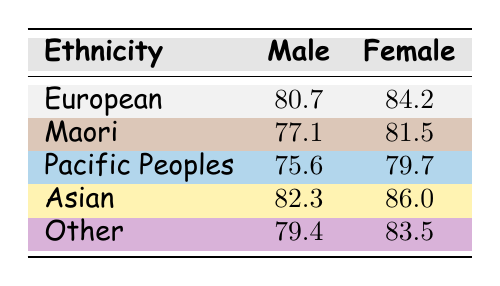What is the life expectancy of European males? The table shows that the life expectancy of European males is listed under the "Male" column for the "European" ethnicity, which is 80.7 years.
Answer: 80.7 What is the life expectancy of Maori females? The table specifies that the life expectancy of Maori females is 81.5 years, found under the "Female" column for the "Maori" ethnicity.
Answer: 81.5 Which demographic has the highest life expectancy for females? By checking the "Female" life expectancy values, we find that Asian females have the highest life expectancy at 86.0 years. This is greater than the values for other ethnicities.
Answer: Asian What is the difference in life expectancy between Pacific Peoples males and Asian males? The life expectancy for Pacific Peoples males is 75.6 years, while for Asian males it is 82.3 years. The difference is calculated as 82.3 - 75.6 = 6.7 years.
Answer: 6.7 Is the life expectancy of Maori males higher than that of Pacific Peoples males? For Maori males, the life expectancy is 77.1 years, and for Pacific Peoples males, it is 75.6 years. Since 77.1 is greater than 75.6, the answer is yes.
Answer: Yes What is the average life expectancy for females across all demographics? To find the average, first sum the life expectancies of females: 84.2 + 81.5 + 79.7 + 86.0 + 83.5 = 415. The total number of demographics is 5, so the average is 415 / 5 = 83.0.
Answer: 83.0 Which demographic has the lowest life expectancy for males? Reviewing the table, we find that Pacific Peoples males have the lowest life expectancy at 75.6 years, which is less than that of all other demographics listed.
Answer: Pacific Peoples How does the life expectancy of Other females compare to that of Asian females? The life expectancy of Other females is 83.5 years, while Asian females have a life expectancy of 86.0 years. Since 83.5 is less than 86.0, it means Other females have a lower life expectancy than Asian females.
Answer: Lower than 